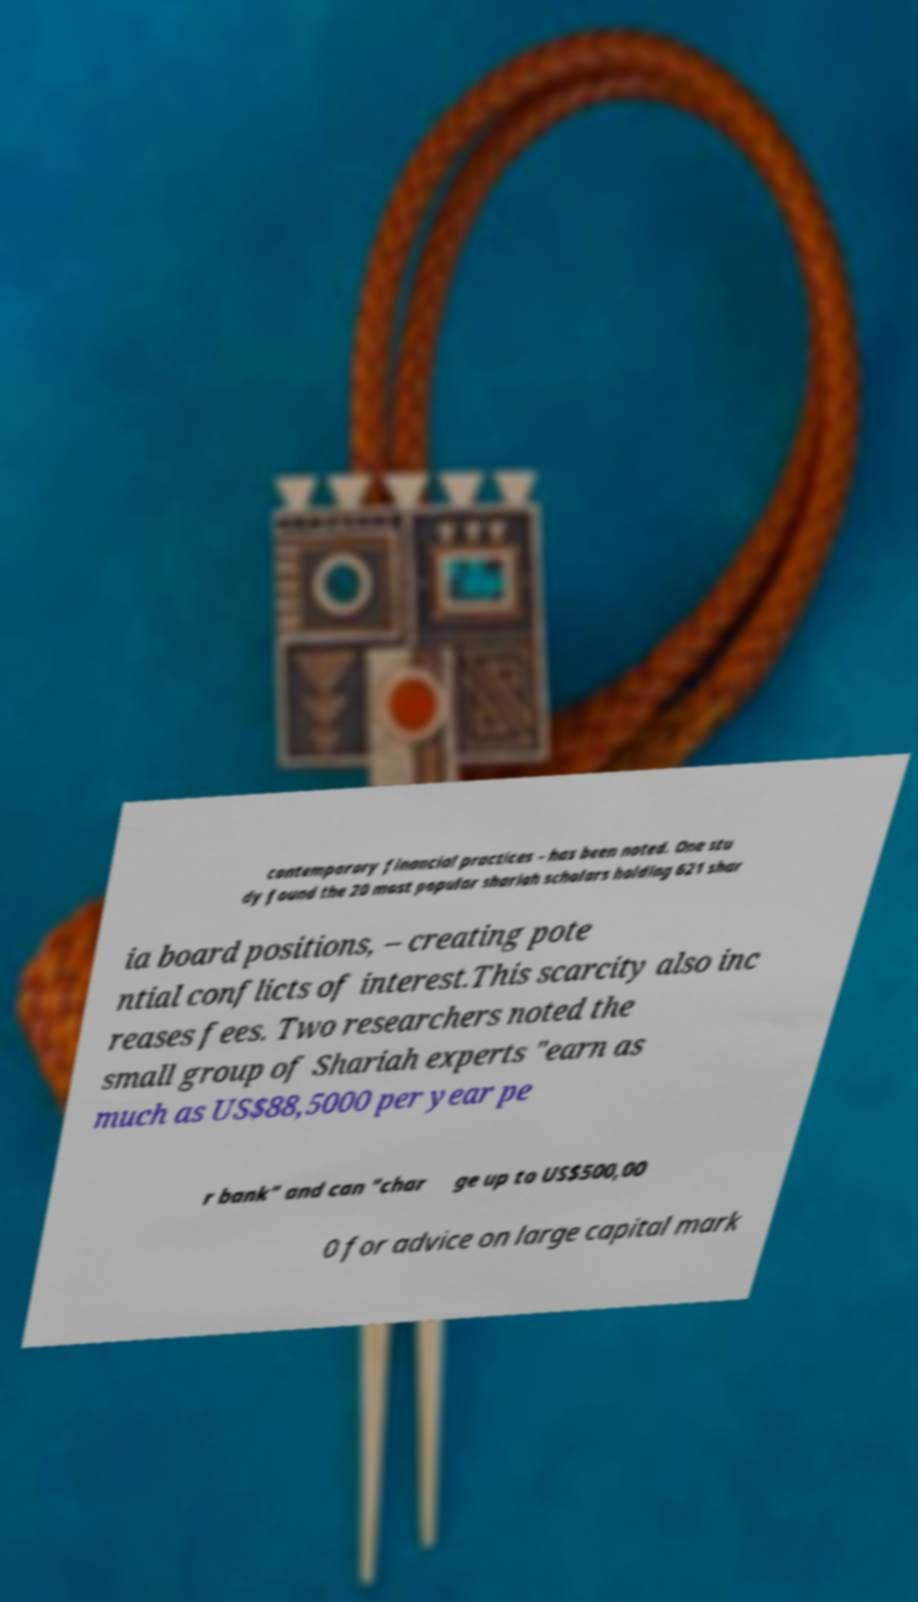Please read and relay the text visible in this image. What does it say? contemporary financial practices – has been noted. One stu dy found the 20 most popular shariah scholars holding 621 shar ia board positions, – creating pote ntial conflicts of interest.This scarcity also inc reases fees. Two researchers noted the small group of Shariah experts "earn as much as US$88,5000 per year pe r bank" and can "char ge up to US$500,00 0 for advice on large capital mark 